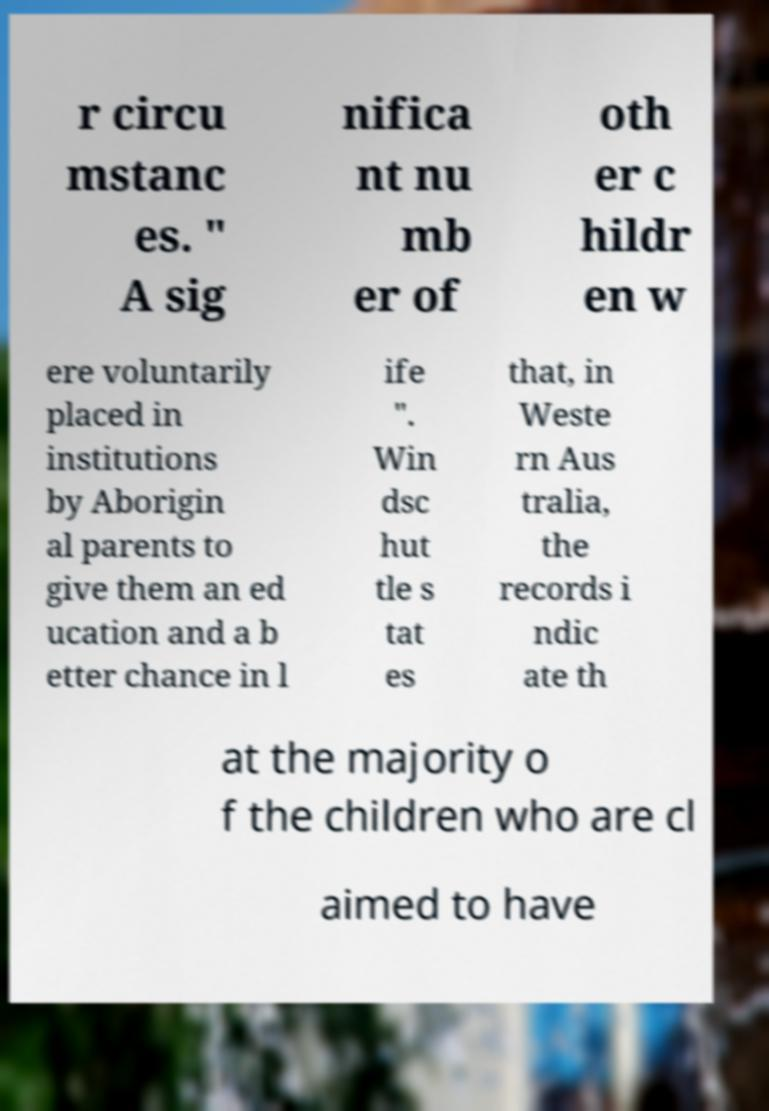What messages or text are displayed in this image? I need them in a readable, typed format. r circu mstanc es. " A sig nifica nt nu mb er of oth er c hildr en w ere voluntarily placed in institutions by Aborigin al parents to give them an ed ucation and a b etter chance in l ife ". Win dsc hut tle s tat es that, in Weste rn Aus tralia, the records i ndic ate th at the majority o f the children who are cl aimed to have 